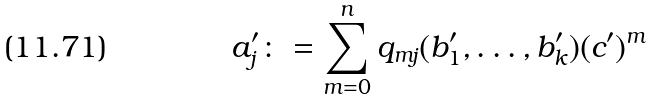<formula> <loc_0><loc_0><loc_500><loc_500>a _ { j } ^ { \prime } \colon = \sum _ { m = 0 } ^ { n } q _ { m j } ( b _ { 1 } ^ { \prime } , \dots , b _ { k } ^ { \prime } ) ( c ^ { \prime } ) ^ { m }</formula> 